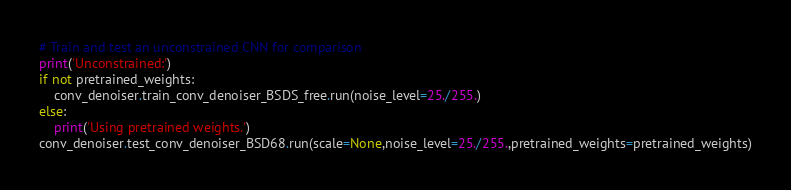<code> <loc_0><loc_0><loc_500><loc_500><_Python_># Train and test an unconstrained CNN for comparison
print('Unconstrained:')
if not pretrained_weights:
    conv_denoiser.train_conv_denoiser_BSDS_free.run(noise_level=25./255.)
else:
    print('Using pretrained weights.')
conv_denoiser.test_conv_denoiser_BSD68.run(scale=None,noise_level=25./255.,pretrained_weights=pretrained_weights)

</code> 